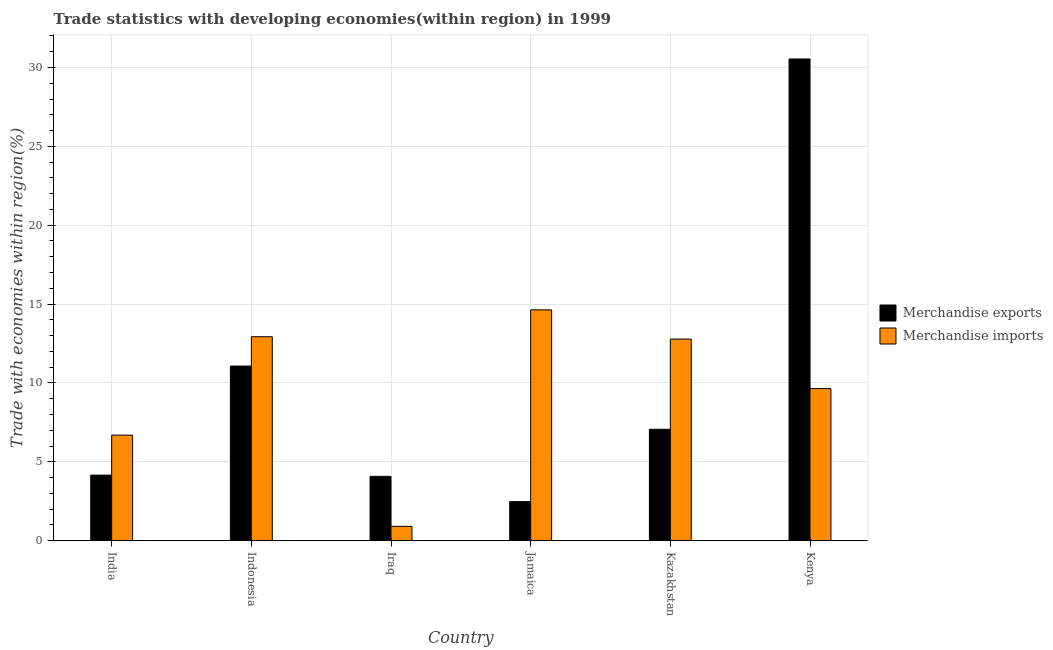What is the label of the 5th group of bars from the left?
Keep it short and to the point. Kazakhstan. What is the merchandise exports in India?
Give a very brief answer. 4.16. Across all countries, what is the maximum merchandise imports?
Provide a succinct answer. 14.63. Across all countries, what is the minimum merchandise imports?
Your response must be concise. 0.91. In which country was the merchandise exports maximum?
Provide a succinct answer. Kenya. In which country was the merchandise imports minimum?
Provide a short and direct response. Iraq. What is the total merchandise exports in the graph?
Your response must be concise. 59.39. What is the difference between the merchandise imports in India and that in Kazakhstan?
Your answer should be very brief. -6.09. What is the difference between the merchandise imports in Indonesia and the merchandise exports in Iraq?
Provide a short and direct response. 8.85. What is the average merchandise exports per country?
Provide a short and direct response. 9.9. What is the difference between the merchandise exports and merchandise imports in Iraq?
Offer a very short reply. 3.17. What is the ratio of the merchandise exports in India to that in Iraq?
Your answer should be compact. 1.02. Is the merchandise imports in Jamaica less than that in Kenya?
Your response must be concise. No. Is the difference between the merchandise exports in Indonesia and Kenya greater than the difference between the merchandise imports in Indonesia and Kenya?
Give a very brief answer. No. What is the difference between the highest and the second highest merchandise imports?
Provide a short and direct response. 1.7. What is the difference between the highest and the lowest merchandise imports?
Give a very brief answer. 13.72. In how many countries, is the merchandise imports greater than the average merchandise imports taken over all countries?
Make the answer very short. 4. What does the 1st bar from the left in Kenya represents?
Ensure brevity in your answer.  Merchandise exports. What does the 1st bar from the right in Indonesia represents?
Your answer should be compact. Merchandise imports. What is the difference between two consecutive major ticks on the Y-axis?
Make the answer very short. 5. Does the graph contain grids?
Provide a succinct answer. Yes. How are the legend labels stacked?
Offer a terse response. Vertical. What is the title of the graph?
Make the answer very short. Trade statistics with developing economies(within region) in 1999. What is the label or title of the Y-axis?
Your response must be concise. Trade with economies within region(%). What is the Trade with economies within region(%) of Merchandise exports in India?
Your answer should be very brief. 4.16. What is the Trade with economies within region(%) of Merchandise imports in India?
Your answer should be very brief. 6.69. What is the Trade with economies within region(%) in Merchandise exports in Indonesia?
Your answer should be compact. 11.07. What is the Trade with economies within region(%) of Merchandise imports in Indonesia?
Your answer should be very brief. 12.93. What is the Trade with economies within region(%) of Merchandise exports in Iraq?
Your answer should be very brief. 4.08. What is the Trade with economies within region(%) of Merchandise imports in Iraq?
Give a very brief answer. 0.91. What is the Trade with economies within region(%) in Merchandise exports in Jamaica?
Keep it short and to the point. 2.48. What is the Trade with economies within region(%) in Merchandise imports in Jamaica?
Provide a succinct answer. 14.63. What is the Trade with economies within region(%) in Merchandise exports in Kazakhstan?
Offer a very short reply. 7.06. What is the Trade with economies within region(%) in Merchandise imports in Kazakhstan?
Offer a very short reply. 12.78. What is the Trade with economies within region(%) of Merchandise exports in Kenya?
Keep it short and to the point. 30.54. What is the Trade with economies within region(%) in Merchandise imports in Kenya?
Offer a very short reply. 9.64. Across all countries, what is the maximum Trade with economies within region(%) in Merchandise exports?
Keep it short and to the point. 30.54. Across all countries, what is the maximum Trade with economies within region(%) of Merchandise imports?
Your response must be concise. 14.63. Across all countries, what is the minimum Trade with economies within region(%) in Merchandise exports?
Offer a very short reply. 2.48. Across all countries, what is the minimum Trade with economies within region(%) in Merchandise imports?
Provide a succinct answer. 0.91. What is the total Trade with economies within region(%) in Merchandise exports in the graph?
Provide a succinct answer. 59.39. What is the total Trade with economies within region(%) in Merchandise imports in the graph?
Make the answer very short. 57.6. What is the difference between the Trade with economies within region(%) in Merchandise exports in India and that in Indonesia?
Offer a terse response. -6.91. What is the difference between the Trade with economies within region(%) in Merchandise imports in India and that in Indonesia?
Your answer should be compact. -6.24. What is the difference between the Trade with economies within region(%) of Merchandise exports in India and that in Iraq?
Provide a succinct answer. 0.08. What is the difference between the Trade with economies within region(%) in Merchandise imports in India and that in Iraq?
Keep it short and to the point. 5.78. What is the difference between the Trade with economies within region(%) in Merchandise exports in India and that in Jamaica?
Your response must be concise. 1.68. What is the difference between the Trade with economies within region(%) in Merchandise imports in India and that in Jamaica?
Provide a succinct answer. -7.94. What is the difference between the Trade with economies within region(%) of Merchandise exports in India and that in Kazakhstan?
Provide a succinct answer. -2.9. What is the difference between the Trade with economies within region(%) of Merchandise imports in India and that in Kazakhstan?
Ensure brevity in your answer.  -6.09. What is the difference between the Trade with economies within region(%) of Merchandise exports in India and that in Kenya?
Ensure brevity in your answer.  -26.38. What is the difference between the Trade with economies within region(%) of Merchandise imports in India and that in Kenya?
Make the answer very short. -2.95. What is the difference between the Trade with economies within region(%) in Merchandise exports in Indonesia and that in Iraq?
Keep it short and to the point. 6.99. What is the difference between the Trade with economies within region(%) of Merchandise imports in Indonesia and that in Iraq?
Offer a very short reply. 12.02. What is the difference between the Trade with economies within region(%) in Merchandise exports in Indonesia and that in Jamaica?
Offer a terse response. 8.6. What is the difference between the Trade with economies within region(%) in Merchandise imports in Indonesia and that in Jamaica?
Your answer should be compact. -1.7. What is the difference between the Trade with economies within region(%) of Merchandise exports in Indonesia and that in Kazakhstan?
Offer a very short reply. 4.01. What is the difference between the Trade with economies within region(%) of Merchandise imports in Indonesia and that in Kazakhstan?
Your answer should be very brief. 0.15. What is the difference between the Trade with economies within region(%) of Merchandise exports in Indonesia and that in Kenya?
Make the answer very short. -19.47. What is the difference between the Trade with economies within region(%) in Merchandise imports in Indonesia and that in Kenya?
Ensure brevity in your answer.  3.29. What is the difference between the Trade with economies within region(%) of Merchandise exports in Iraq and that in Jamaica?
Keep it short and to the point. 1.6. What is the difference between the Trade with economies within region(%) of Merchandise imports in Iraq and that in Jamaica?
Your answer should be very brief. -13.72. What is the difference between the Trade with economies within region(%) in Merchandise exports in Iraq and that in Kazakhstan?
Give a very brief answer. -2.98. What is the difference between the Trade with economies within region(%) of Merchandise imports in Iraq and that in Kazakhstan?
Keep it short and to the point. -11.87. What is the difference between the Trade with economies within region(%) of Merchandise exports in Iraq and that in Kenya?
Ensure brevity in your answer.  -26.46. What is the difference between the Trade with economies within region(%) in Merchandise imports in Iraq and that in Kenya?
Give a very brief answer. -8.73. What is the difference between the Trade with economies within region(%) of Merchandise exports in Jamaica and that in Kazakhstan?
Provide a succinct answer. -4.59. What is the difference between the Trade with economies within region(%) of Merchandise imports in Jamaica and that in Kazakhstan?
Offer a terse response. 1.85. What is the difference between the Trade with economies within region(%) of Merchandise exports in Jamaica and that in Kenya?
Keep it short and to the point. -28.06. What is the difference between the Trade with economies within region(%) of Merchandise imports in Jamaica and that in Kenya?
Make the answer very short. 4.99. What is the difference between the Trade with economies within region(%) of Merchandise exports in Kazakhstan and that in Kenya?
Keep it short and to the point. -23.48. What is the difference between the Trade with economies within region(%) in Merchandise imports in Kazakhstan and that in Kenya?
Your answer should be compact. 3.14. What is the difference between the Trade with economies within region(%) of Merchandise exports in India and the Trade with economies within region(%) of Merchandise imports in Indonesia?
Keep it short and to the point. -8.77. What is the difference between the Trade with economies within region(%) in Merchandise exports in India and the Trade with economies within region(%) in Merchandise imports in Iraq?
Make the answer very short. 3.25. What is the difference between the Trade with economies within region(%) of Merchandise exports in India and the Trade with economies within region(%) of Merchandise imports in Jamaica?
Give a very brief answer. -10.48. What is the difference between the Trade with economies within region(%) in Merchandise exports in India and the Trade with economies within region(%) in Merchandise imports in Kazakhstan?
Ensure brevity in your answer.  -8.62. What is the difference between the Trade with economies within region(%) of Merchandise exports in India and the Trade with economies within region(%) of Merchandise imports in Kenya?
Provide a short and direct response. -5.49. What is the difference between the Trade with economies within region(%) in Merchandise exports in Indonesia and the Trade with economies within region(%) in Merchandise imports in Iraq?
Give a very brief answer. 10.16. What is the difference between the Trade with economies within region(%) of Merchandise exports in Indonesia and the Trade with economies within region(%) of Merchandise imports in Jamaica?
Your answer should be compact. -3.56. What is the difference between the Trade with economies within region(%) of Merchandise exports in Indonesia and the Trade with economies within region(%) of Merchandise imports in Kazakhstan?
Your answer should be very brief. -1.71. What is the difference between the Trade with economies within region(%) of Merchandise exports in Indonesia and the Trade with economies within region(%) of Merchandise imports in Kenya?
Your answer should be compact. 1.43. What is the difference between the Trade with economies within region(%) of Merchandise exports in Iraq and the Trade with economies within region(%) of Merchandise imports in Jamaica?
Your answer should be compact. -10.55. What is the difference between the Trade with economies within region(%) of Merchandise exports in Iraq and the Trade with economies within region(%) of Merchandise imports in Kazakhstan?
Keep it short and to the point. -8.7. What is the difference between the Trade with economies within region(%) of Merchandise exports in Iraq and the Trade with economies within region(%) of Merchandise imports in Kenya?
Keep it short and to the point. -5.56. What is the difference between the Trade with economies within region(%) in Merchandise exports in Jamaica and the Trade with economies within region(%) in Merchandise imports in Kazakhstan?
Give a very brief answer. -10.3. What is the difference between the Trade with economies within region(%) in Merchandise exports in Jamaica and the Trade with economies within region(%) in Merchandise imports in Kenya?
Keep it short and to the point. -7.17. What is the difference between the Trade with economies within region(%) of Merchandise exports in Kazakhstan and the Trade with economies within region(%) of Merchandise imports in Kenya?
Your answer should be very brief. -2.58. What is the average Trade with economies within region(%) of Merchandise exports per country?
Provide a short and direct response. 9.9. What is the average Trade with economies within region(%) of Merchandise imports per country?
Provide a succinct answer. 9.6. What is the difference between the Trade with economies within region(%) of Merchandise exports and Trade with economies within region(%) of Merchandise imports in India?
Provide a short and direct response. -2.53. What is the difference between the Trade with economies within region(%) in Merchandise exports and Trade with economies within region(%) in Merchandise imports in Indonesia?
Ensure brevity in your answer.  -1.86. What is the difference between the Trade with economies within region(%) in Merchandise exports and Trade with economies within region(%) in Merchandise imports in Iraq?
Provide a succinct answer. 3.17. What is the difference between the Trade with economies within region(%) of Merchandise exports and Trade with economies within region(%) of Merchandise imports in Jamaica?
Give a very brief answer. -12.16. What is the difference between the Trade with economies within region(%) in Merchandise exports and Trade with economies within region(%) in Merchandise imports in Kazakhstan?
Your response must be concise. -5.72. What is the difference between the Trade with economies within region(%) in Merchandise exports and Trade with economies within region(%) in Merchandise imports in Kenya?
Provide a succinct answer. 20.89. What is the ratio of the Trade with economies within region(%) of Merchandise exports in India to that in Indonesia?
Ensure brevity in your answer.  0.38. What is the ratio of the Trade with economies within region(%) of Merchandise imports in India to that in Indonesia?
Your answer should be very brief. 0.52. What is the ratio of the Trade with economies within region(%) in Merchandise exports in India to that in Iraq?
Make the answer very short. 1.02. What is the ratio of the Trade with economies within region(%) in Merchandise imports in India to that in Iraq?
Provide a short and direct response. 7.33. What is the ratio of the Trade with economies within region(%) in Merchandise exports in India to that in Jamaica?
Offer a terse response. 1.68. What is the ratio of the Trade with economies within region(%) in Merchandise imports in India to that in Jamaica?
Keep it short and to the point. 0.46. What is the ratio of the Trade with economies within region(%) in Merchandise exports in India to that in Kazakhstan?
Ensure brevity in your answer.  0.59. What is the ratio of the Trade with economies within region(%) in Merchandise imports in India to that in Kazakhstan?
Offer a very short reply. 0.52. What is the ratio of the Trade with economies within region(%) in Merchandise exports in India to that in Kenya?
Provide a succinct answer. 0.14. What is the ratio of the Trade with economies within region(%) of Merchandise imports in India to that in Kenya?
Make the answer very short. 0.69. What is the ratio of the Trade with economies within region(%) in Merchandise exports in Indonesia to that in Iraq?
Provide a short and direct response. 2.71. What is the ratio of the Trade with economies within region(%) in Merchandise imports in Indonesia to that in Iraq?
Provide a short and direct response. 14.16. What is the ratio of the Trade with economies within region(%) of Merchandise exports in Indonesia to that in Jamaica?
Offer a terse response. 4.47. What is the ratio of the Trade with economies within region(%) in Merchandise imports in Indonesia to that in Jamaica?
Your answer should be very brief. 0.88. What is the ratio of the Trade with economies within region(%) of Merchandise exports in Indonesia to that in Kazakhstan?
Make the answer very short. 1.57. What is the ratio of the Trade with economies within region(%) of Merchandise imports in Indonesia to that in Kazakhstan?
Your response must be concise. 1.01. What is the ratio of the Trade with economies within region(%) of Merchandise exports in Indonesia to that in Kenya?
Make the answer very short. 0.36. What is the ratio of the Trade with economies within region(%) of Merchandise imports in Indonesia to that in Kenya?
Offer a terse response. 1.34. What is the ratio of the Trade with economies within region(%) of Merchandise exports in Iraq to that in Jamaica?
Provide a succinct answer. 1.65. What is the ratio of the Trade with economies within region(%) of Merchandise imports in Iraq to that in Jamaica?
Keep it short and to the point. 0.06. What is the ratio of the Trade with economies within region(%) of Merchandise exports in Iraq to that in Kazakhstan?
Provide a short and direct response. 0.58. What is the ratio of the Trade with economies within region(%) of Merchandise imports in Iraq to that in Kazakhstan?
Your answer should be compact. 0.07. What is the ratio of the Trade with economies within region(%) of Merchandise exports in Iraq to that in Kenya?
Give a very brief answer. 0.13. What is the ratio of the Trade with economies within region(%) in Merchandise imports in Iraq to that in Kenya?
Make the answer very short. 0.09. What is the ratio of the Trade with economies within region(%) in Merchandise exports in Jamaica to that in Kazakhstan?
Your answer should be compact. 0.35. What is the ratio of the Trade with economies within region(%) in Merchandise imports in Jamaica to that in Kazakhstan?
Your answer should be very brief. 1.15. What is the ratio of the Trade with economies within region(%) of Merchandise exports in Jamaica to that in Kenya?
Give a very brief answer. 0.08. What is the ratio of the Trade with economies within region(%) in Merchandise imports in Jamaica to that in Kenya?
Offer a terse response. 1.52. What is the ratio of the Trade with economies within region(%) of Merchandise exports in Kazakhstan to that in Kenya?
Offer a very short reply. 0.23. What is the ratio of the Trade with economies within region(%) of Merchandise imports in Kazakhstan to that in Kenya?
Your answer should be compact. 1.33. What is the difference between the highest and the second highest Trade with economies within region(%) in Merchandise exports?
Offer a terse response. 19.47. What is the difference between the highest and the second highest Trade with economies within region(%) of Merchandise imports?
Provide a succinct answer. 1.7. What is the difference between the highest and the lowest Trade with economies within region(%) of Merchandise exports?
Your answer should be very brief. 28.06. What is the difference between the highest and the lowest Trade with economies within region(%) of Merchandise imports?
Make the answer very short. 13.72. 